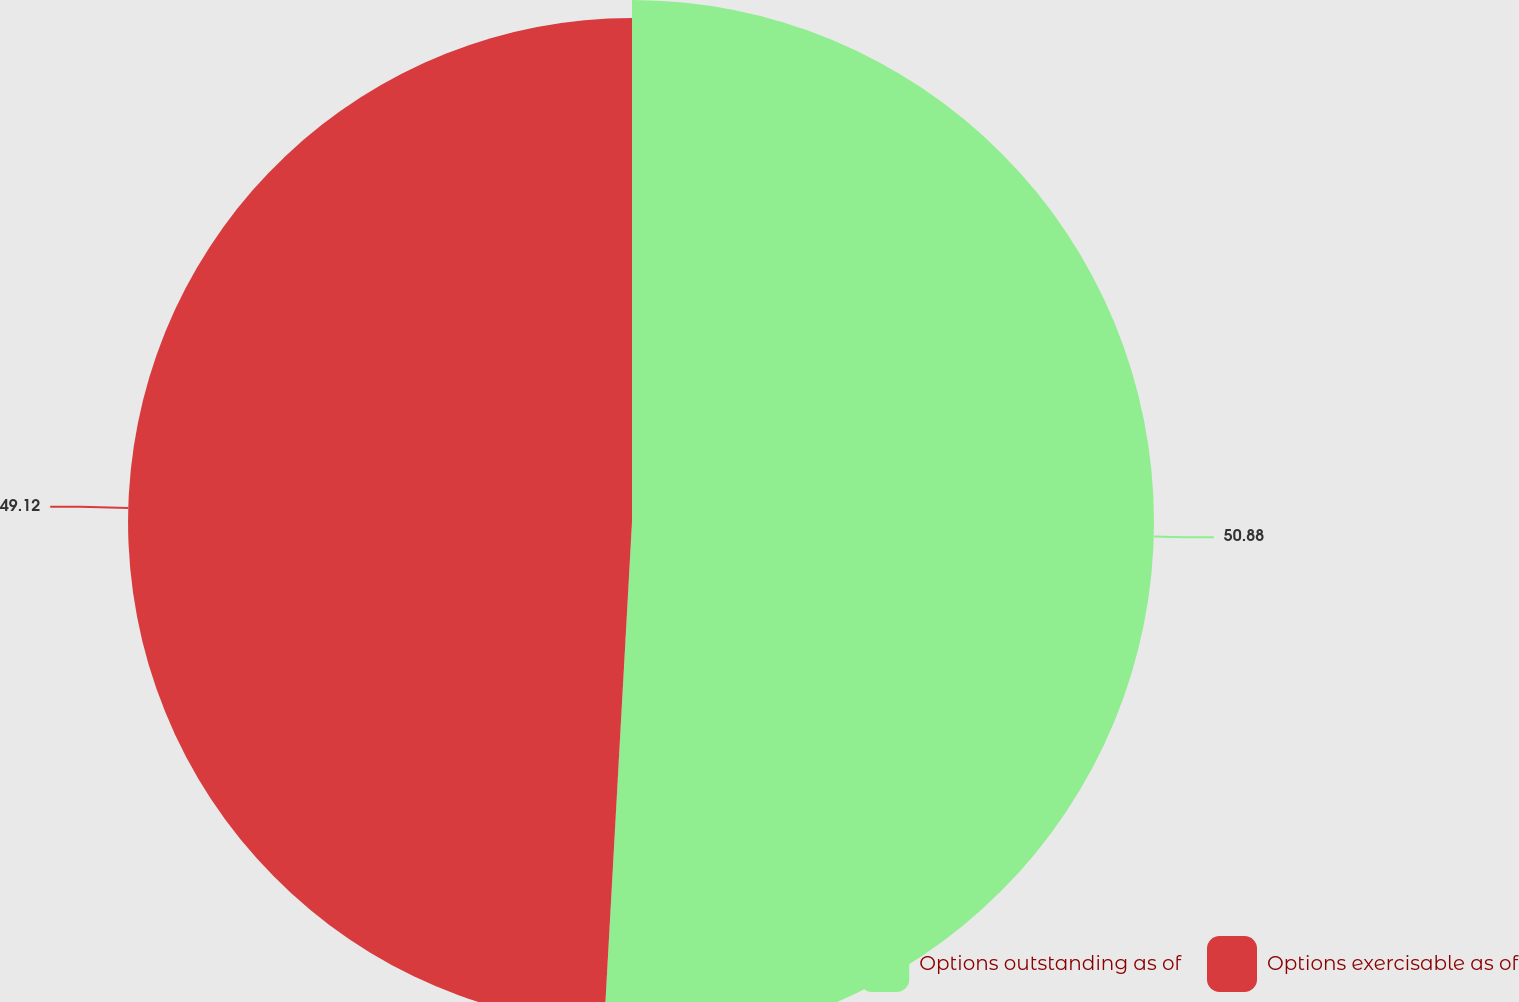Convert chart. <chart><loc_0><loc_0><loc_500><loc_500><pie_chart><fcel>Options outstanding as of<fcel>Options exercisable as of<nl><fcel>50.88%<fcel>49.12%<nl></chart> 